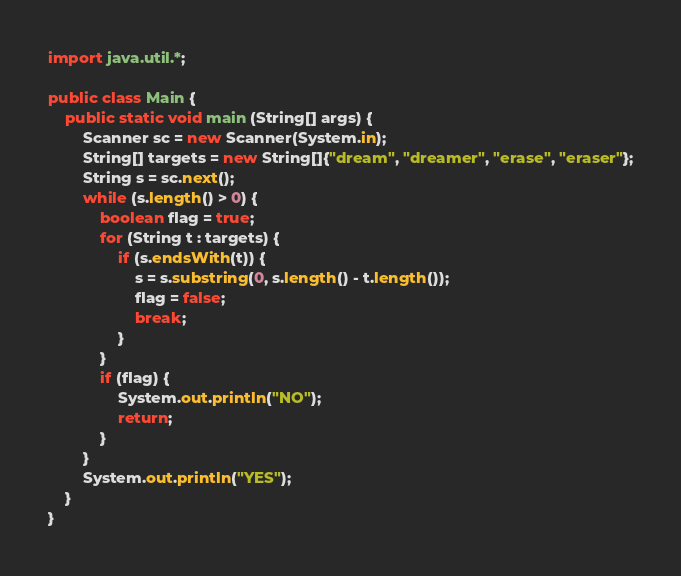Convert code to text. <code><loc_0><loc_0><loc_500><loc_500><_Java_>import java.util.*;

public class Main {
	public static void main (String[] args) {
		Scanner sc = new Scanner(System.in);
		String[] targets = new String[]{"dream", "dreamer", "erase", "eraser"};
		String s = sc.next();
		while (s.length() > 0) {
			boolean flag = true;
			for (String t : targets) {
				if (s.endsWith(t)) {
					s = s.substring(0, s.length() - t.length());
					flag = false;
					break;
				}
			}
			if (flag) {
				System.out.println("NO");
				return;
			}
		}
		System.out.println("YES");
	}
}
</code> 